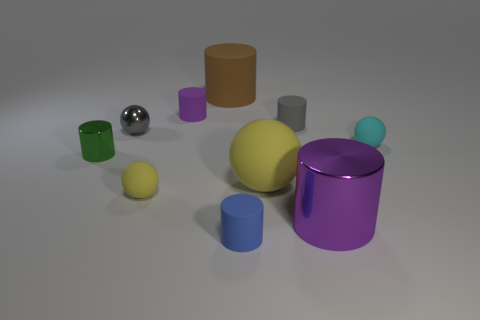Is the size of the purple thing that is behind the big metal thing the same as the yellow rubber ball on the right side of the blue rubber cylinder?
Keep it short and to the point. No. How many objects are either gray objects on the left side of the small purple object or metal balls?
Keep it short and to the point. 1. What material is the tiny purple object?
Provide a short and direct response. Rubber. Do the blue matte object and the metal sphere have the same size?
Your answer should be very brief. Yes. What number of cubes are brown things or big matte objects?
Your response must be concise. 0. There is a small ball left of the small yellow sphere that is on the right side of the small metallic cylinder; what is its color?
Make the answer very short. Gray. Are there fewer small matte cylinders behind the big rubber cylinder than big things to the left of the big metallic thing?
Your answer should be very brief. Yes. Do the purple shiny thing and the purple cylinder behind the green metallic thing have the same size?
Your answer should be compact. No. There is a object that is right of the large yellow rubber ball and behind the cyan rubber thing; what is its shape?
Offer a very short reply. Cylinder. The brown object that is the same material as the cyan sphere is what size?
Your answer should be very brief. Large. 